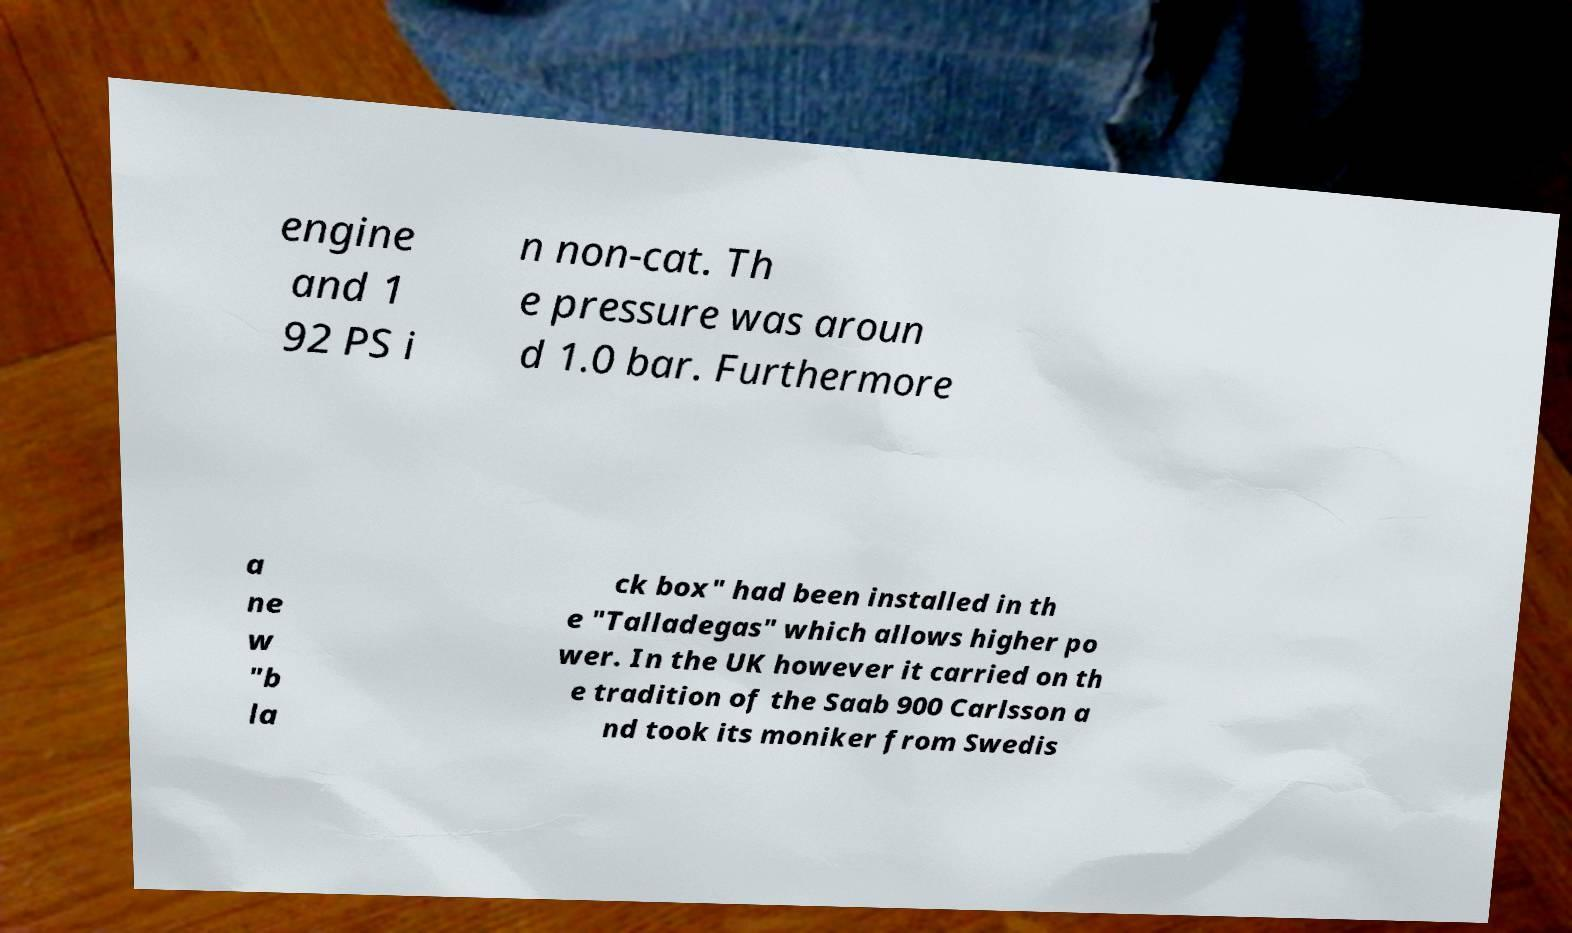There's text embedded in this image that I need extracted. Can you transcribe it verbatim? engine and 1 92 PS i n non-cat. Th e pressure was aroun d 1.0 bar. Furthermore a ne w "b la ck box" had been installed in th e "Talladegas" which allows higher po wer. In the UK however it carried on th e tradition of the Saab 900 Carlsson a nd took its moniker from Swedis 